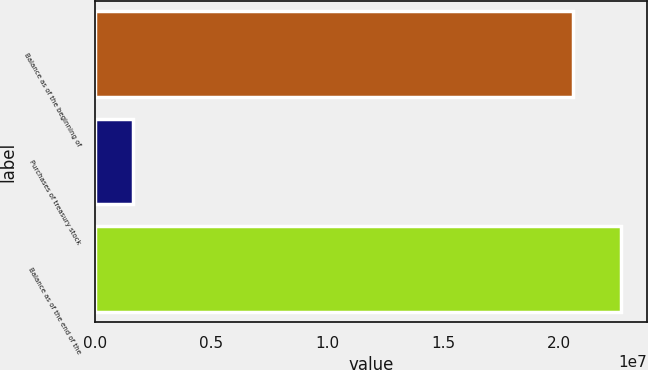Convert chart to OTSL. <chart><loc_0><loc_0><loc_500><loc_500><bar_chart><fcel>Balance as of the beginning of<fcel>Purchases of treasury stock<fcel>Balance as of the end of the<nl><fcel>2.06017e+07<fcel>1.66759e+06<fcel>2.26619e+07<nl></chart> 